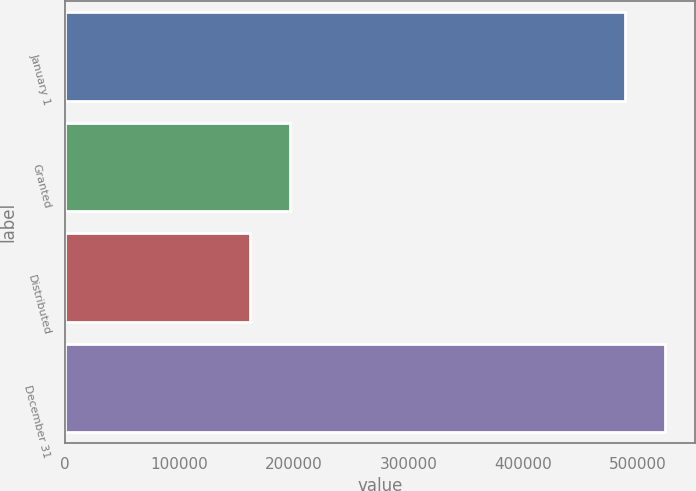Convert chart to OTSL. <chart><loc_0><loc_0><loc_500><loc_500><bar_chart><fcel>January 1<fcel>Granted<fcel>Distributed<fcel>December 31<nl><fcel>488887<fcel>196447<fcel>161625<fcel>523709<nl></chart> 